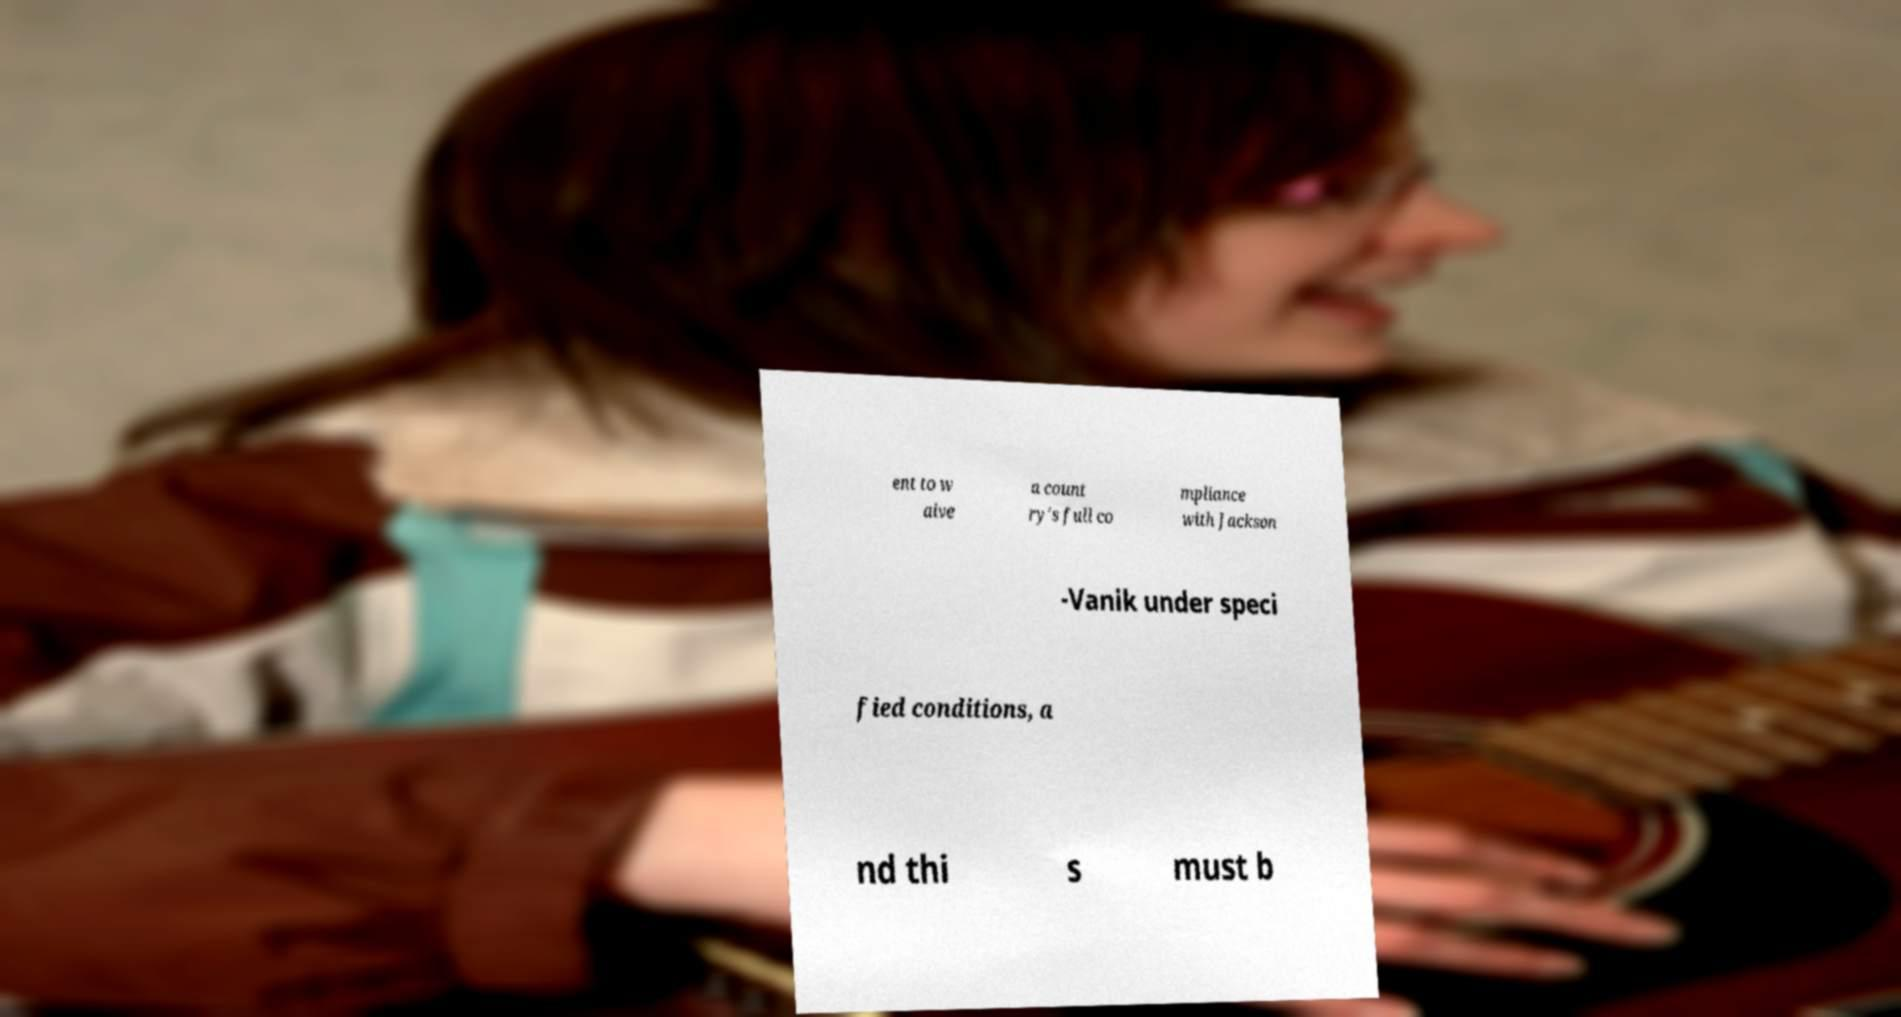Please identify and transcribe the text found in this image. ent to w aive a count ry's full co mpliance with Jackson -Vanik under speci fied conditions, a nd thi s must b 